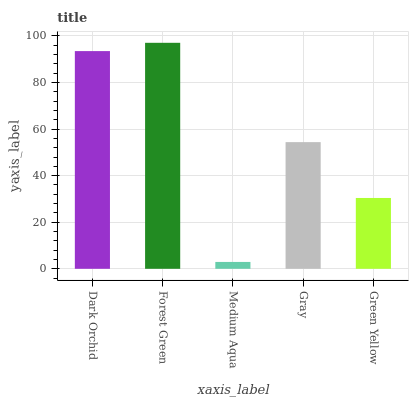Is Medium Aqua the minimum?
Answer yes or no. Yes. Is Forest Green the maximum?
Answer yes or no. Yes. Is Forest Green the minimum?
Answer yes or no. No. Is Medium Aqua the maximum?
Answer yes or no. No. Is Forest Green greater than Medium Aqua?
Answer yes or no. Yes. Is Medium Aqua less than Forest Green?
Answer yes or no. Yes. Is Medium Aqua greater than Forest Green?
Answer yes or no. No. Is Forest Green less than Medium Aqua?
Answer yes or no. No. Is Gray the high median?
Answer yes or no. Yes. Is Gray the low median?
Answer yes or no. Yes. Is Dark Orchid the high median?
Answer yes or no. No. Is Medium Aqua the low median?
Answer yes or no. No. 